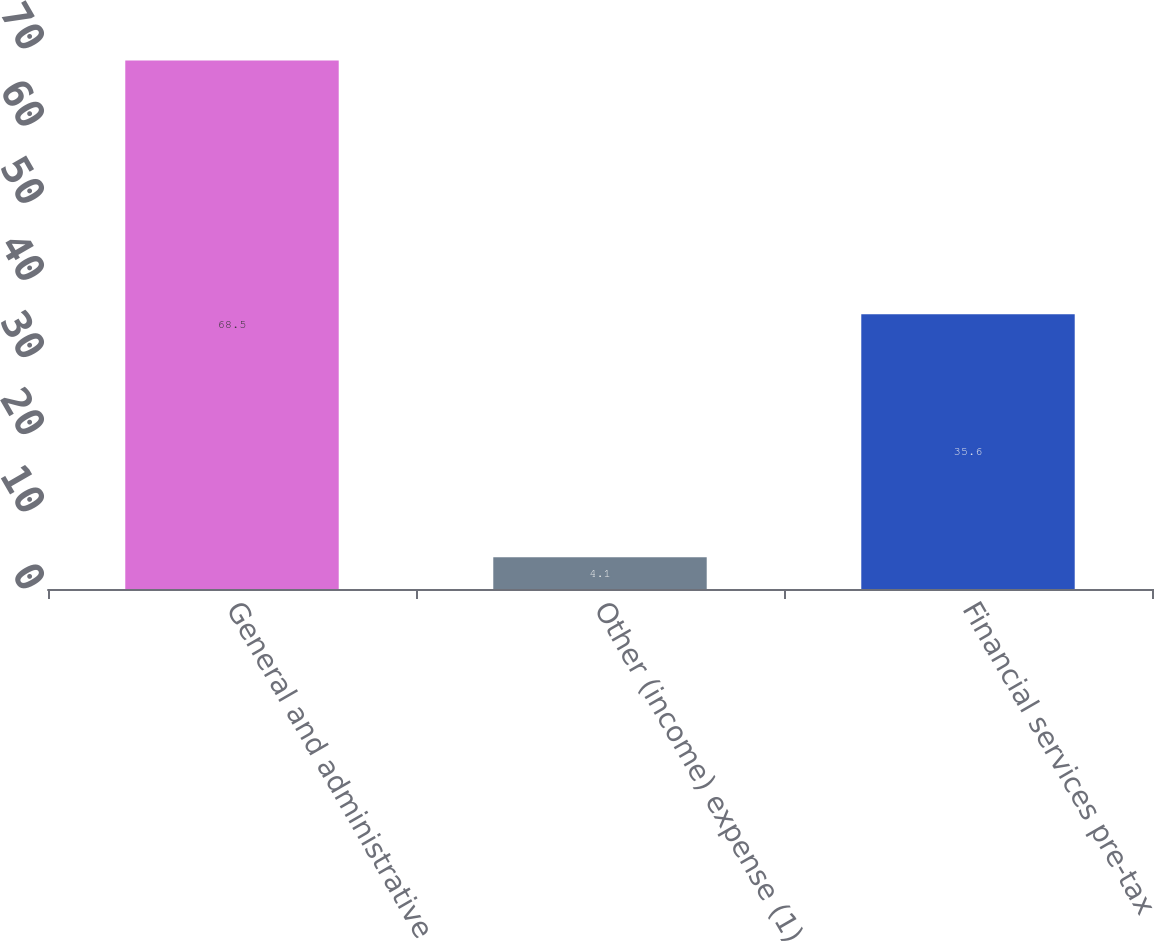Convert chart. <chart><loc_0><loc_0><loc_500><loc_500><bar_chart><fcel>General and administrative<fcel>Other (income) expense (1)<fcel>Financial services pre-tax<nl><fcel>68.5<fcel>4.1<fcel>35.6<nl></chart> 